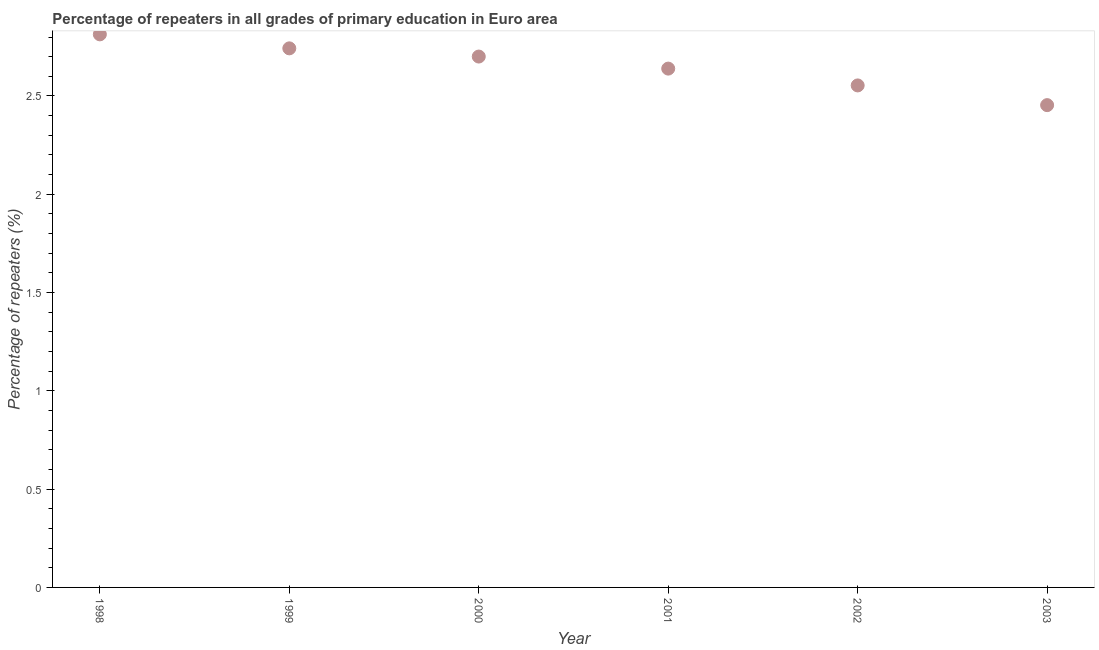What is the percentage of repeaters in primary education in 2002?
Ensure brevity in your answer.  2.55. Across all years, what is the maximum percentage of repeaters in primary education?
Your answer should be compact. 2.81. Across all years, what is the minimum percentage of repeaters in primary education?
Provide a short and direct response. 2.45. In which year was the percentage of repeaters in primary education maximum?
Offer a very short reply. 1998. In which year was the percentage of repeaters in primary education minimum?
Make the answer very short. 2003. What is the sum of the percentage of repeaters in primary education?
Offer a very short reply. 15.9. What is the difference between the percentage of repeaters in primary education in 1999 and 2001?
Offer a very short reply. 0.1. What is the average percentage of repeaters in primary education per year?
Make the answer very short. 2.65. What is the median percentage of repeaters in primary education?
Ensure brevity in your answer.  2.67. In how many years, is the percentage of repeaters in primary education greater than 1 %?
Your response must be concise. 6. What is the ratio of the percentage of repeaters in primary education in 2001 to that in 2002?
Provide a short and direct response. 1.03. Is the difference between the percentage of repeaters in primary education in 2002 and 2003 greater than the difference between any two years?
Make the answer very short. No. What is the difference between the highest and the second highest percentage of repeaters in primary education?
Your answer should be compact. 0.07. What is the difference between the highest and the lowest percentage of repeaters in primary education?
Keep it short and to the point. 0.36. In how many years, is the percentage of repeaters in primary education greater than the average percentage of repeaters in primary education taken over all years?
Provide a short and direct response. 3. Does the percentage of repeaters in primary education monotonically increase over the years?
Give a very brief answer. No. Are the values on the major ticks of Y-axis written in scientific E-notation?
Your answer should be very brief. No. Does the graph contain grids?
Your answer should be compact. No. What is the title of the graph?
Your response must be concise. Percentage of repeaters in all grades of primary education in Euro area. What is the label or title of the X-axis?
Your answer should be compact. Year. What is the label or title of the Y-axis?
Give a very brief answer. Percentage of repeaters (%). What is the Percentage of repeaters (%) in 1998?
Provide a succinct answer. 2.81. What is the Percentage of repeaters (%) in 1999?
Your answer should be very brief. 2.74. What is the Percentage of repeaters (%) in 2000?
Ensure brevity in your answer.  2.7. What is the Percentage of repeaters (%) in 2001?
Offer a terse response. 2.64. What is the Percentage of repeaters (%) in 2002?
Provide a short and direct response. 2.55. What is the Percentage of repeaters (%) in 2003?
Give a very brief answer. 2.45. What is the difference between the Percentage of repeaters (%) in 1998 and 1999?
Your response must be concise. 0.07. What is the difference between the Percentage of repeaters (%) in 1998 and 2000?
Give a very brief answer. 0.11. What is the difference between the Percentage of repeaters (%) in 1998 and 2001?
Keep it short and to the point. 0.17. What is the difference between the Percentage of repeaters (%) in 1998 and 2002?
Offer a very short reply. 0.26. What is the difference between the Percentage of repeaters (%) in 1998 and 2003?
Provide a short and direct response. 0.36. What is the difference between the Percentage of repeaters (%) in 1999 and 2000?
Provide a short and direct response. 0.04. What is the difference between the Percentage of repeaters (%) in 1999 and 2001?
Give a very brief answer. 0.1. What is the difference between the Percentage of repeaters (%) in 1999 and 2002?
Provide a succinct answer. 0.19. What is the difference between the Percentage of repeaters (%) in 1999 and 2003?
Offer a very short reply. 0.29. What is the difference between the Percentage of repeaters (%) in 2000 and 2001?
Give a very brief answer. 0.06. What is the difference between the Percentage of repeaters (%) in 2000 and 2002?
Keep it short and to the point. 0.15. What is the difference between the Percentage of repeaters (%) in 2000 and 2003?
Your answer should be very brief. 0.25. What is the difference between the Percentage of repeaters (%) in 2001 and 2002?
Keep it short and to the point. 0.09. What is the difference between the Percentage of repeaters (%) in 2001 and 2003?
Offer a terse response. 0.19. What is the difference between the Percentage of repeaters (%) in 2002 and 2003?
Provide a short and direct response. 0.1. What is the ratio of the Percentage of repeaters (%) in 1998 to that in 1999?
Your answer should be compact. 1.03. What is the ratio of the Percentage of repeaters (%) in 1998 to that in 2000?
Your answer should be very brief. 1.04. What is the ratio of the Percentage of repeaters (%) in 1998 to that in 2001?
Provide a short and direct response. 1.07. What is the ratio of the Percentage of repeaters (%) in 1998 to that in 2002?
Make the answer very short. 1.1. What is the ratio of the Percentage of repeaters (%) in 1998 to that in 2003?
Provide a short and direct response. 1.15. What is the ratio of the Percentage of repeaters (%) in 1999 to that in 2000?
Ensure brevity in your answer.  1.01. What is the ratio of the Percentage of repeaters (%) in 1999 to that in 2001?
Offer a terse response. 1.04. What is the ratio of the Percentage of repeaters (%) in 1999 to that in 2002?
Ensure brevity in your answer.  1.07. What is the ratio of the Percentage of repeaters (%) in 1999 to that in 2003?
Your answer should be very brief. 1.12. What is the ratio of the Percentage of repeaters (%) in 2000 to that in 2002?
Your answer should be very brief. 1.06. What is the ratio of the Percentage of repeaters (%) in 2000 to that in 2003?
Make the answer very short. 1.1. What is the ratio of the Percentage of repeaters (%) in 2001 to that in 2002?
Offer a terse response. 1.03. What is the ratio of the Percentage of repeaters (%) in 2001 to that in 2003?
Offer a very short reply. 1.08. What is the ratio of the Percentage of repeaters (%) in 2002 to that in 2003?
Offer a terse response. 1.04. 